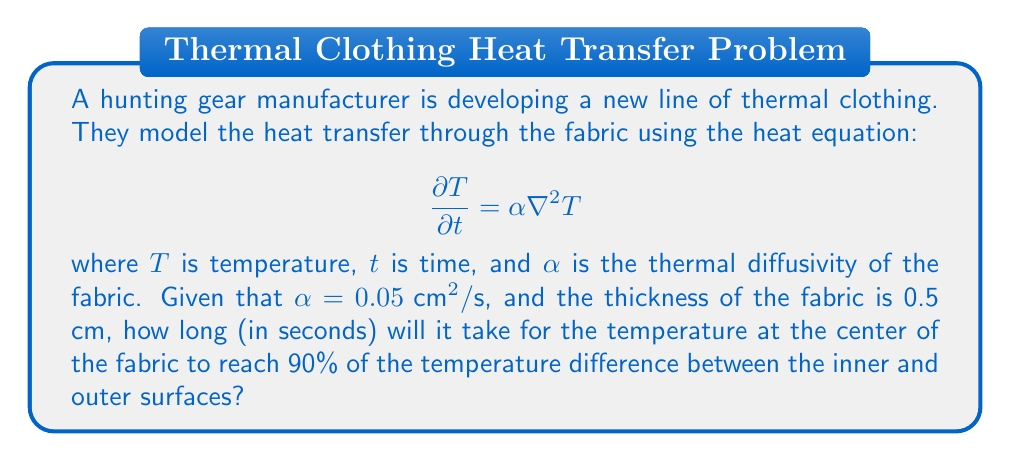Provide a solution to this math problem. To solve this problem, we'll use the following steps:

1) For a slab of thickness $L$, the temperature distribution can be approximated by:

   $$T(x,t) = T_1 + (T_2 - T_1)\left(1 - \frac{4}{\pi}\sum_{n=0}^{\infty}\frac{(-1)^n}{2n+1}e^{-\alpha(2n+1)^2\pi^2t/L^2}\cos\frac{(2n+1)\pi x}{L}\right)$$

   where $T_1$ is the initial temperature and $T_2$ is the final temperature.

2) At the center of the fabric ($x = L/2$), this simplifies to:

   $$T(L/2,t) = T_1 + (T_2 - T_1)\left(1 - \frac{4}{\pi}\sum_{n=0}^{\infty}\frac{1}{2n+1}e^{-\alpha(2n+1)^2\pi^2t/L^2}\right)$$

3) We want to find $t$ when $T(L/2,t) = 0.9(T_2 - T_1) + T_1$. Substituting this:

   $$0.9 = 1 - \frac{4}{\pi}\sum_{n=0}^{\infty}\frac{1}{2n+1}e^{-\alpha(2n+1)^2\pi^2t/L^2}$$

4) This equation can't be solved analytically, but we can approximate it by considering only the first term of the series:

   $$0.9 \approx 1 - \frac{4}{\pi}e^{-\alpha\pi^2t/L^2}$$

5) Solving for $t$:

   $$t \approx -\frac{L^2}{\alpha\pi^2}\ln\left(\frac{0.1\pi}{4}\right)$$

6) Substituting the given values ($L = 0.5$ cm, $\alpha = 0.05 \text{ cm}^2/\text{s}$):

   $$t \approx -\frac{(0.5)^2}{0.05\pi^2}\ln\left(\frac{0.1\pi}{4}\right) \approx 0.8086 \text{ seconds}$$

Therefore, it will take approximately 0.81 seconds for the temperature at the center of the fabric to reach 90% of the temperature difference.
Answer: 0.81 seconds 